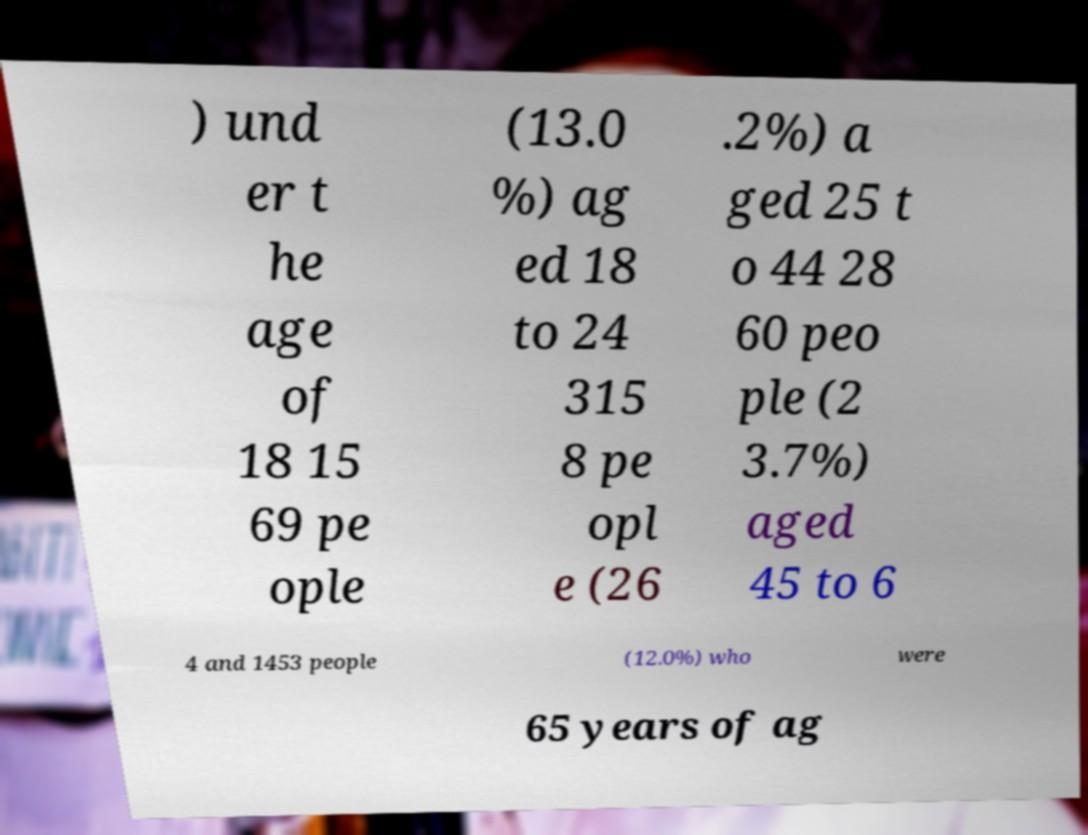Could you extract and type out the text from this image? ) und er t he age of 18 15 69 pe ople (13.0 %) ag ed 18 to 24 315 8 pe opl e (26 .2%) a ged 25 t o 44 28 60 peo ple (2 3.7%) aged 45 to 6 4 and 1453 people (12.0%) who were 65 years of ag 